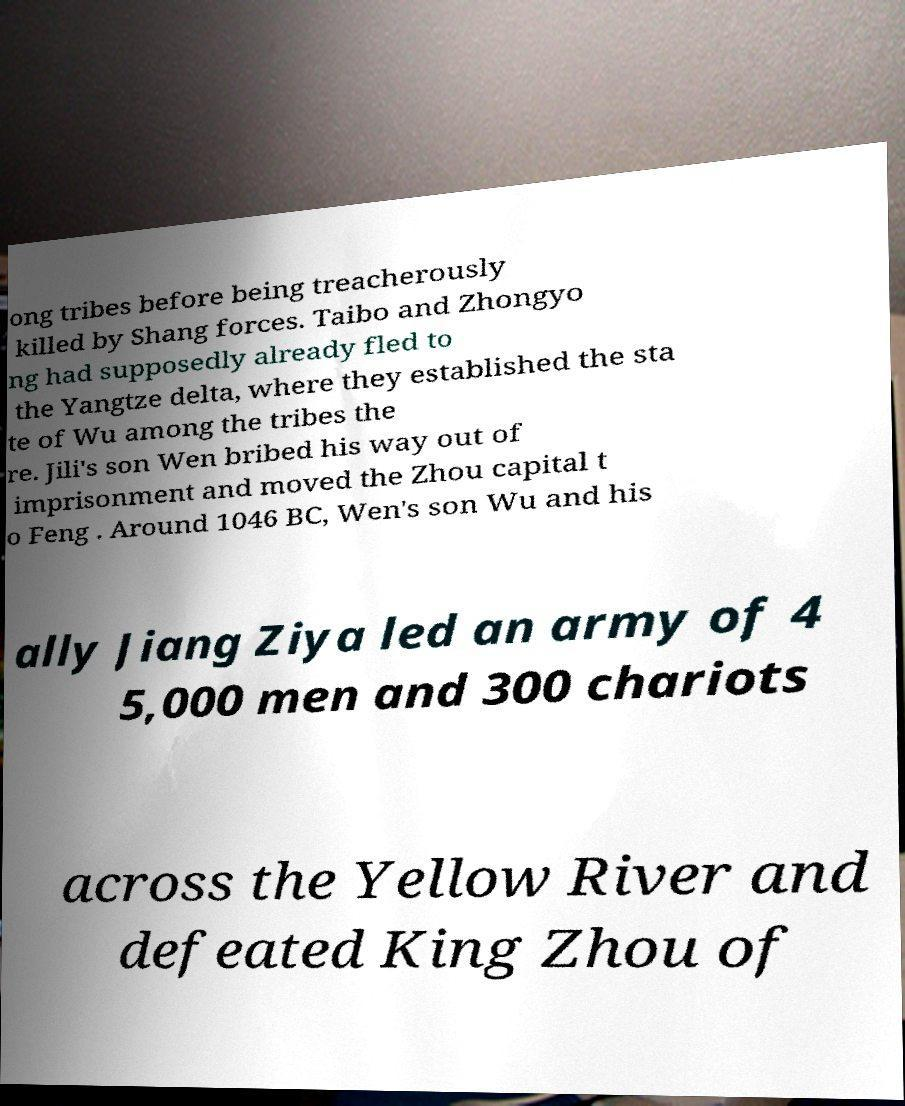Could you assist in decoding the text presented in this image and type it out clearly? ong tribes before being treacherously killed by Shang forces. Taibo and Zhongyo ng had supposedly already fled to the Yangtze delta, where they established the sta te of Wu among the tribes the re. Jili's son Wen bribed his way out of imprisonment and moved the Zhou capital t o Feng . Around 1046 BC, Wen's son Wu and his ally Jiang Ziya led an army of 4 5,000 men and 300 chariots across the Yellow River and defeated King Zhou of 